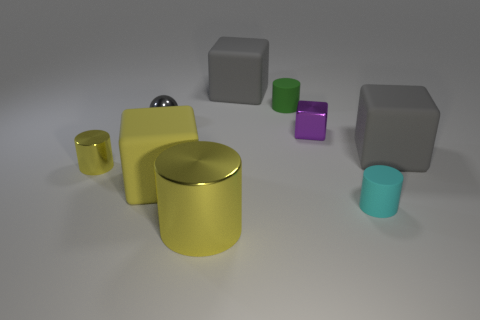Can you infer any purpose or function for the arrangement of these objects? The arrangement of objects does not suggest a specific purpose or function as they are scattered randomly, which could imply an abstract or aesthetic intent rather than a practical one. It could be a part of a visual composition designed to showcase contrast in colors, materials, and geometry among everyday objects, perhaps for an artistic or educational display. 